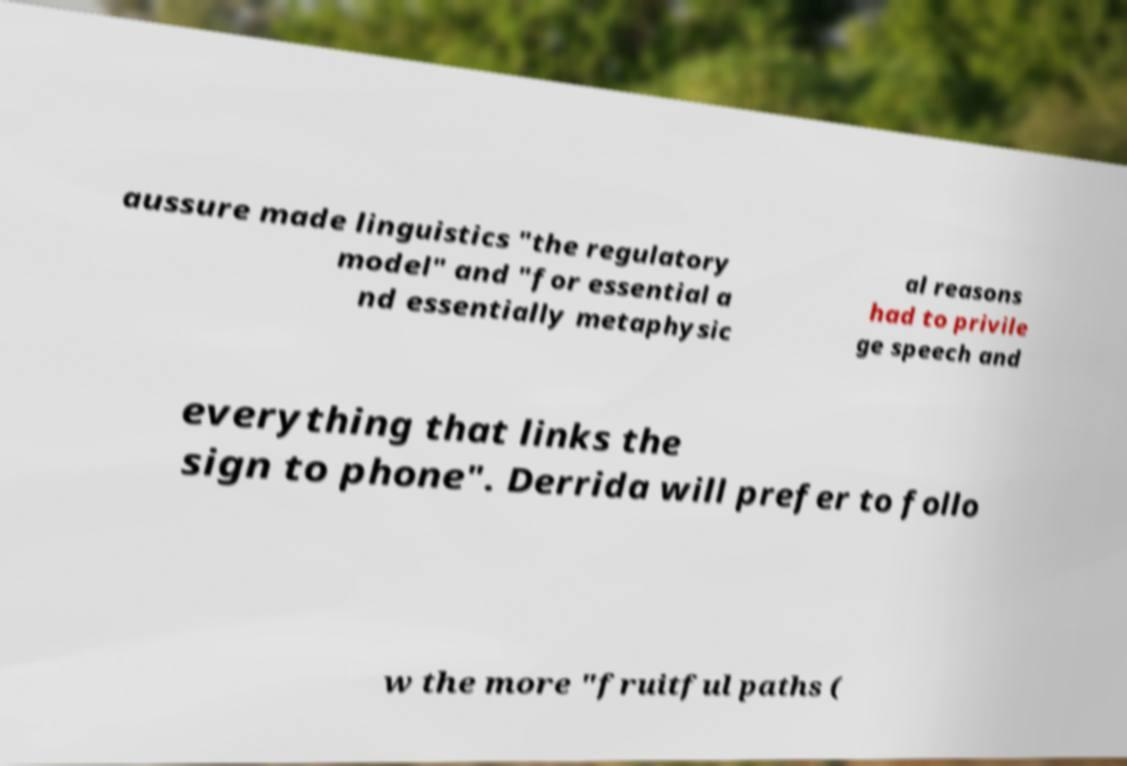For documentation purposes, I need the text within this image transcribed. Could you provide that? aussure made linguistics "the regulatory model" and "for essential a nd essentially metaphysic al reasons had to privile ge speech and everything that links the sign to phone". Derrida will prefer to follo w the more "fruitful paths ( 